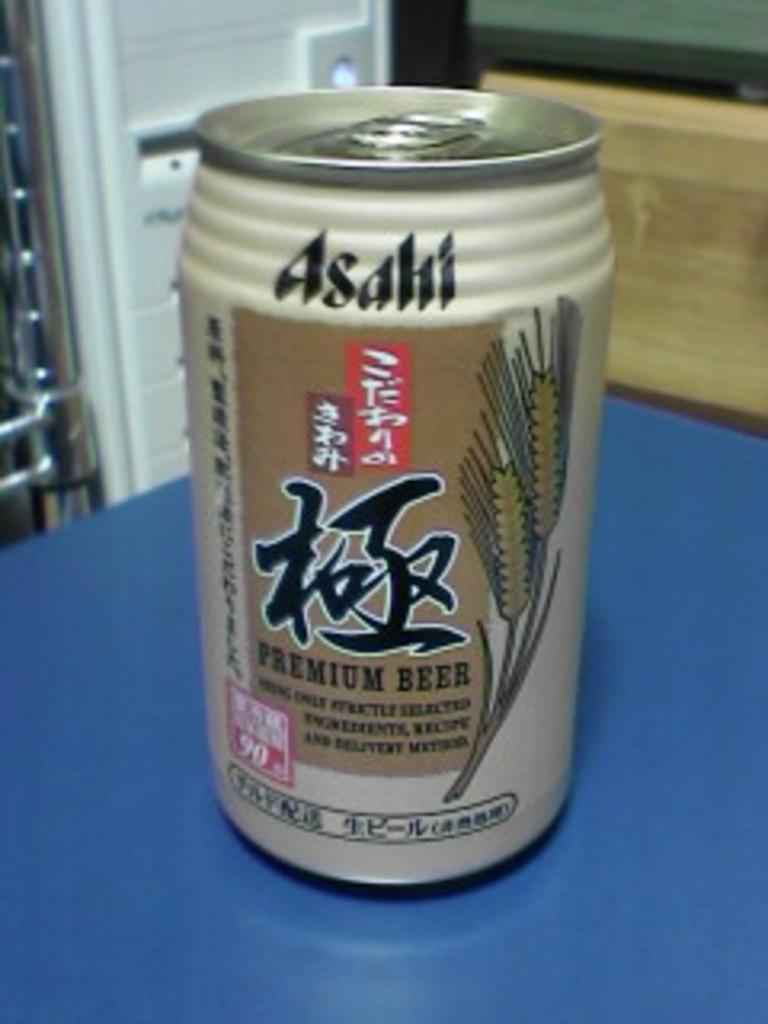What is the main object visible in the image? There is a coke tin in the image. Where is the coke tin located? The coke tin is on a table. What type of beast is shown interacting with the coke tin in the image? There is no beast present in the image; it only features a coke tin on a table. What financial interest does the coke tin have in the image? The coke tin is an inanimate object and does not have any financial interests. 